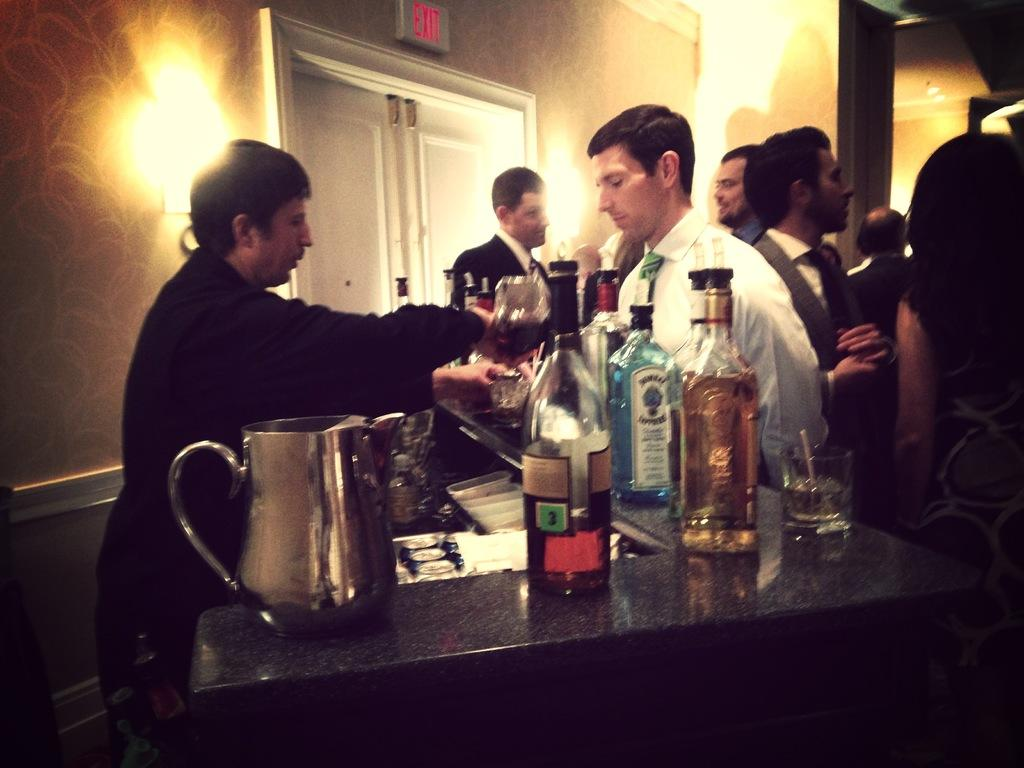<image>
Describe the image concisely. A large liquor bottle on a counter with a green box and a the number 3 label beside other liquor bottles with people surrounding. 